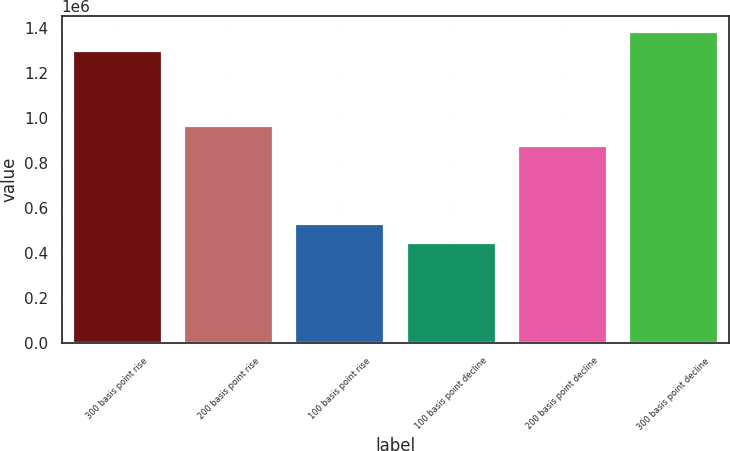Convert chart. <chart><loc_0><loc_0><loc_500><loc_500><bar_chart><fcel>300 basis point rise<fcel>200 basis point rise<fcel>100 basis point rise<fcel>100 basis point decline<fcel>200 basis point decline<fcel>300 basis point decline<nl><fcel>1.2964e+06<fcel>961642<fcel>528540<fcel>443103<fcel>876205<fcel>1.38184e+06<nl></chart> 